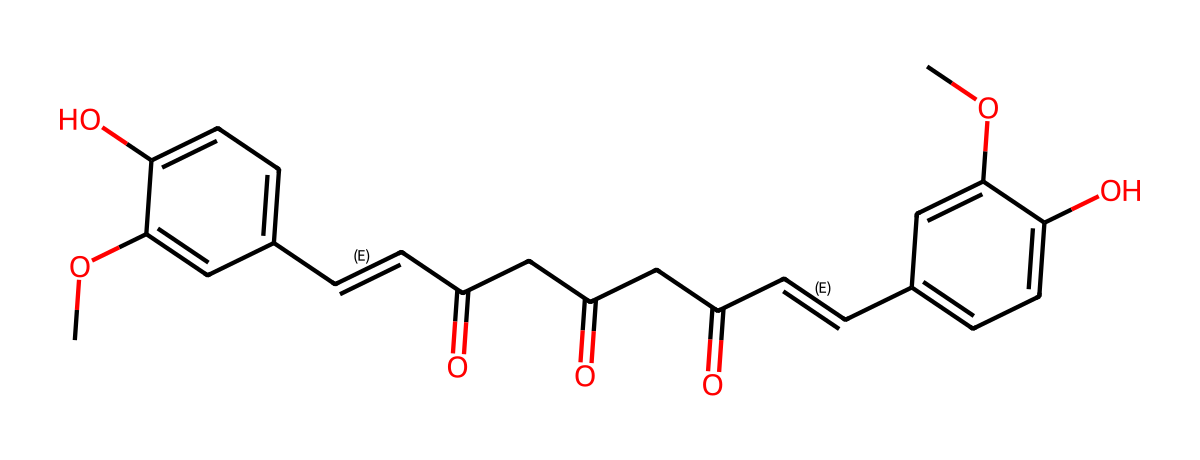What is the molecular formula of curcumin? To determine the molecular formula, we need to count the number of each type of atom in the SMILES representation. The structure contains carbon (C), hydrogen (H), and oxygen (O) atoms. By analyzing the SMILES, we find there are 21 carbon atoms, 20 hydrogen atoms, and 6 oxygen atoms, leading to the molecular formula C21H20O6.
Answer: C21H20O6 How many aromatic rings are present in curcumin? By examining the SMILES representation, we look for the presence of cyclic structures with alternating double bonds, indicative of aromatic rings. There are two distinct parts that show aromatic characteristics, both containing a phenolic structure, thus identifying two aromatic rings in total.
Answer: 2 What type of functional groups does curcumin contain? The structure contains several functional groups: hydroxyl (-OH) from the phenolic parts and carbonyl (C=O) from the keto groups. These are evident from the structure in the SMILES string, specifically, the -OH and the multiple C=O groups mentioned earlier.
Answer: hydroxyl, carbonyl What is the significance of the conjugated double bonds in curcumin? The presence of conjugated double bonds enhances the compound's ability to absorb light, important for its function as a photoresist. This also contributes to the overall stability and reactivity of the chemical structure, making it sensitive to UV light.
Answer: light absorption How many carbonyl groups are present in curcumin? The analysis of the SMILES reveals that there are three carbonyl groups located at various parts of the structure. Each carbonyl group is represented by C=O, which is clearly indicated in the SMILES notation.
Answer: 3 Is curcumin considered a natural dye? Yes, due to its ability to impart a yellow color, curcumin is indeed used as a natural dye in various industries, which is a consequence of its specific chemical structure that allows it to absorb light in a certain way.
Answer: yes 